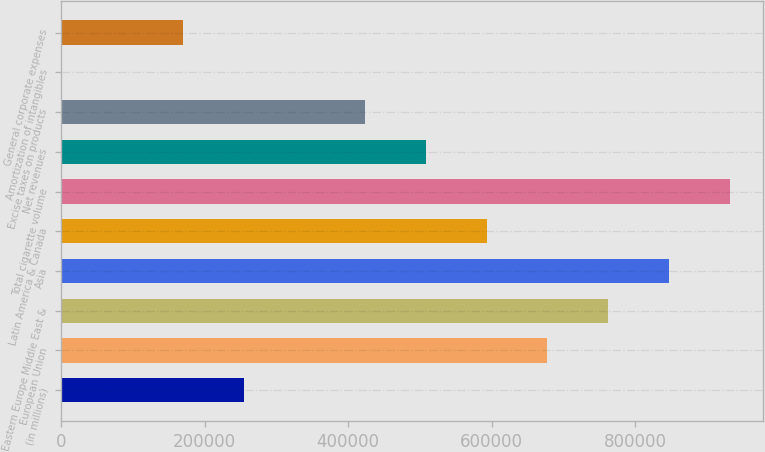Convert chart. <chart><loc_0><loc_0><loc_500><loc_500><bar_chart><fcel>(in millions)<fcel>European Union<fcel>Eastern Europe Middle East &<fcel>Asia<fcel>Latin America & Canada<fcel>Total cigarette volume<fcel>Net revenues<fcel>Excise taxes on products<fcel>Amortization of intangibles<fcel>General corporate expenses<nl><fcel>254238<fcel>677832<fcel>762551<fcel>847270<fcel>593114<fcel>931989<fcel>508395<fcel>423676<fcel>82<fcel>169520<nl></chart> 